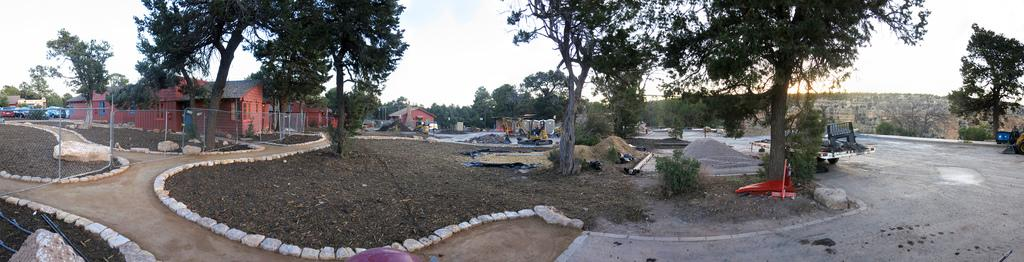What type of structures can be seen in the image? There are buildings in the image. What else is present in the image besides buildings? Motor vehicles, rocks and stones, an excavator, trees, heaps of sand, the ground, and the sky are visible in the image. What might be used for digging or moving earth in the image? An excavator is present in the image for digging or moving earth. What type of natural elements can be seen in the image? Trees are present in the image as a natural element. What is the purpose of the day in the image? The image does not depict a specific day or event, so it is not possible to determine its purpose. What is located on the back of the excavator in the image? There is no information about the back of the excavator in the image, as the focus is on its front and the surrounding environment. 